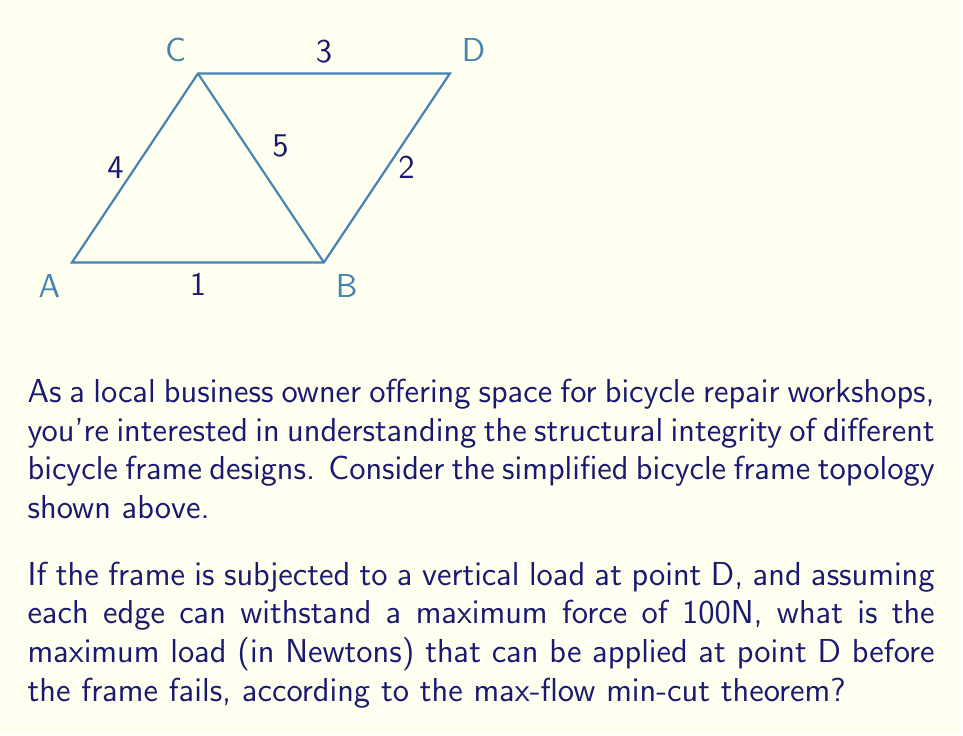Teach me how to tackle this problem. To solve this problem, we'll use the max-flow min-cut theorem from graph theory, which is applicable to the topology of the bicycle frame.

Step 1: Interpret the frame as a network flow problem.
- Consider point A as the source and point D as the sink.
- Each edge represents a path for force distribution with a capacity of 100N.

Step 2: Identify all possible cuts in the graph.
A cut is a partition of the vertices into two disjoint subsets, with the source and sink in different subsets.

Cut 1: {A} | {B,C,D} - Edges: 1, 4
Cut 2: {A,C} | {B,D} - Edges: 1, 5, 2
Cut 3: {A,B} | {C,D} - Edges: 4, 5, 2
Cut 4: {A,B,C} | {D} - Edges: 2, 3

Step 3: Calculate the capacity of each cut.
Cut 1 capacity: 100N + 100N = 200N
Cut 2 capacity: 100N + 100N + 100N = 300N
Cut 3 capacity: 100N + 100N + 100N = 300N
Cut 4 capacity: 100N + 100N = 200N

Step 4: Determine the minimum cut.
The minimum cut is the cut with the smallest capacity, which is 200N (Cut 1 or Cut 4).

Step 5: Apply the max-flow min-cut theorem.
The theorem states that the maximum flow through a network is equal to the capacity of the minimum cut. Therefore, the maximum load that can be applied at point D before the frame fails is 200N.
Answer: 200N 